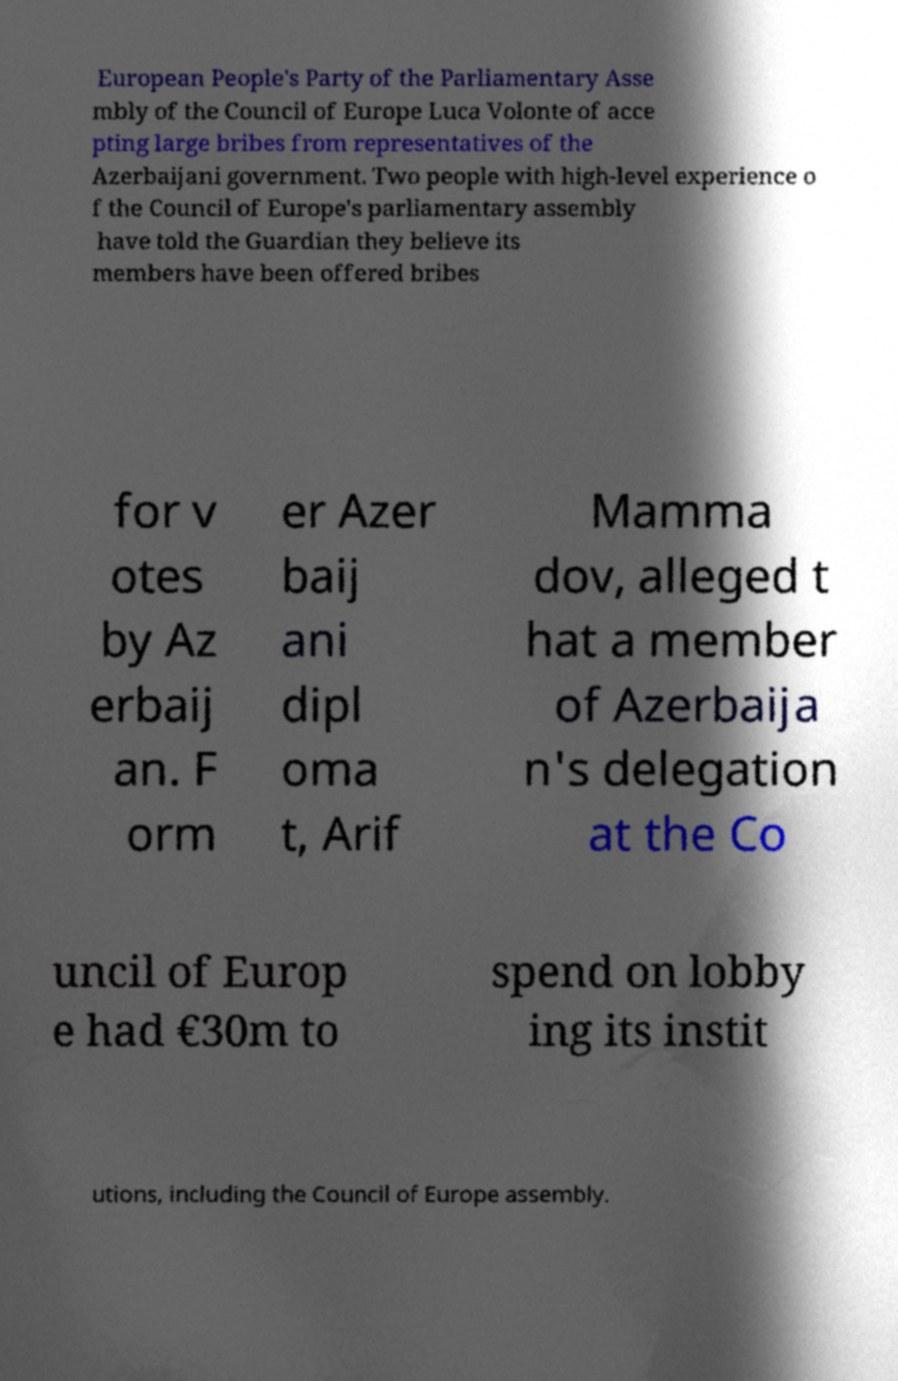Can you read and provide the text displayed in the image?This photo seems to have some interesting text. Can you extract and type it out for me? European People's Party of the Parliamentary Asse mbly of the Council of Europe Luca Volonte of acce pting large bribes from representatives of the Azerbaijani government. Two people with high-level experience o f the Council of Europe's parliamentary assembly have told the Guardian they believe its members have been offered bribes for v otes by Az erbaij an. F orm er Azer baij ani dipl oma t, Arif Mamma dov, alleged t hat a member of Azerbaija n's delegation at the Co uncil of Europ e had €30m to spend on lobby ing its instit utions, including the Council of Europe assembly. 